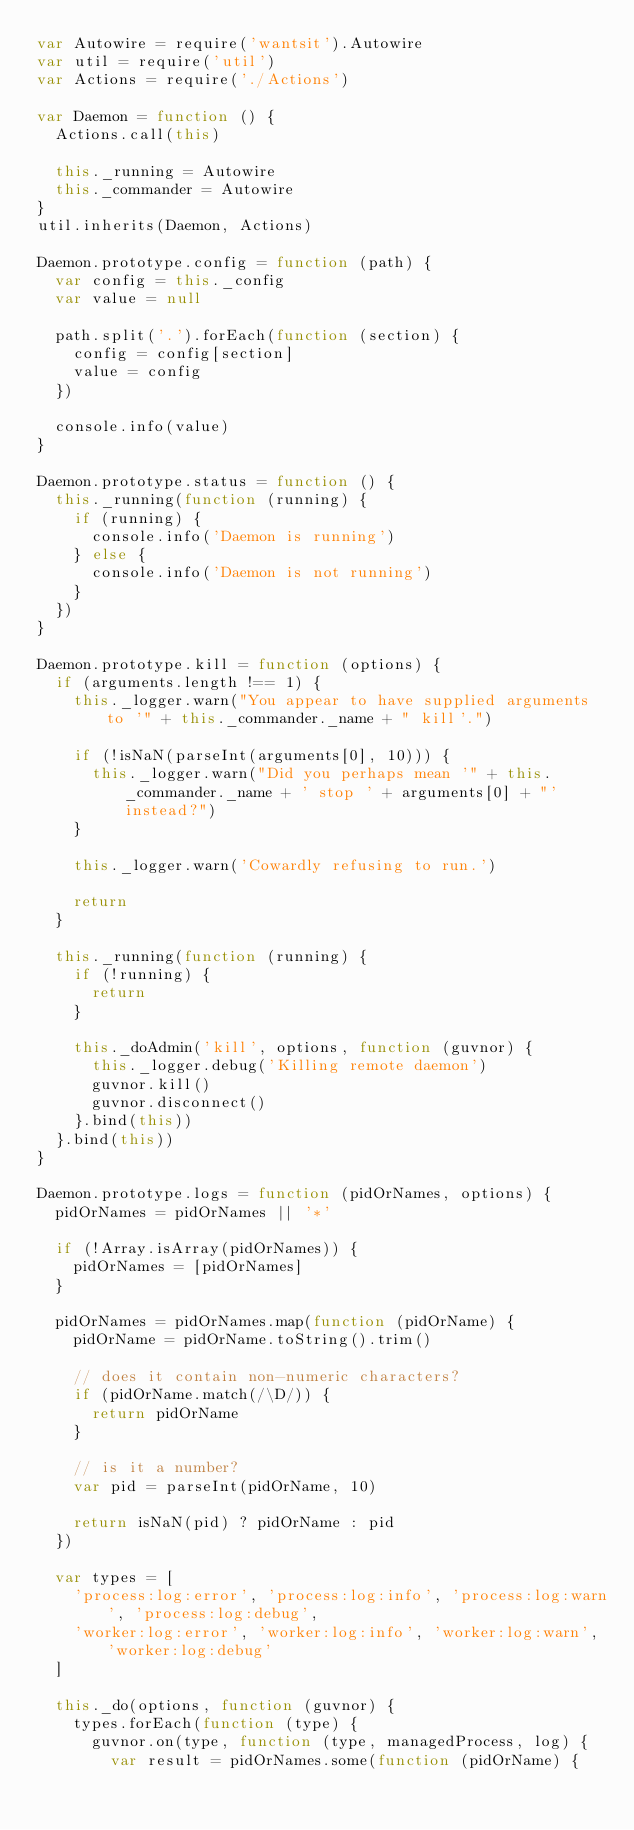<code> <loc_0><loc_0><loc_500><loc_500><_JavaScript_>var Autowire = require('wantsit').Autowire
var util = require('util')
var Actions = require('./Actions')

var Daemon = function () {
  Actions.call(this)

  this._running = Autowire
  this._commander = Autowire
}
util.inherits(Daemon, Actions)

Daemon.prototype.config = function (path) {
  var config = this._config
  var value = null

  path.split('.').forEach(function (section) {
    config = config[section]
    value = config
  })

  console.info(value)
}

Daemon.prototype.status = function () {
  this._running(function (running) {
    if (running) {
      console.info('Daemon is running')
    } else {
      console.info('Daemon is not running')
    }
  })
}

Daemon.prototype.kill = function (options) {
  if (arguments.length !== 1) {
    this._logger.warn("You appear to have supplied arguments to '" + this._commander._name + " kill'.")

    if (!isNaN(parseInt(arguments[0], 10))) {
      this._logger.warn("Did you perhaps mean '" + this._commander._name + ' stop ' + arguments[0] + "' instead?")
    }

    this._logger.warn('Cowardly refusing to run.')

    return
  }

  this._running(function (running) {
    if (!running) {
      return
    }

    this._doAdmin('kill', options, function (guvnor) {
      this._logger.debug('Killing remote daemon')
      guvnor.kill()
      guvnor.disconnect()
    }.bind(this))
  }.bind(this))
}

Daemon.prototype.logs = function (pidOrNames, options) {
  pidOrNames = pidOrNames || '*'

  if (!Array.isArray(pidOrNames)) {
    pidOrNames = [pidOrNames]
  }

  pidOrNames = pidOrNames.map(function (pidOrName) {
    pidOrName = pidOrName.toString().trim()

    // does it contain non-numeric characters?
    if (pidOrName.match(/\D/)) {
      return pidOrName
    }

    // is it a number?
    var pid = parseInt(pidOrName, 10)

    return isNaN(pid) ? pidOrName : pid
  })

  var types = [
    'process:log:error', 'process:log:info', 'process:log:warn', 'process:log:debug',
    'worker:log:error', 'worker:log:info', 'worker:log:warn', 'worker:log:debug'
  ]

  this._do(options, function (guvnor) {
    types.forEach(function (type) {
      guvnor.on(type, function (type, managedProcess, log) {
        var result = pidOrNames.some(function (pidOrName) {</code> 